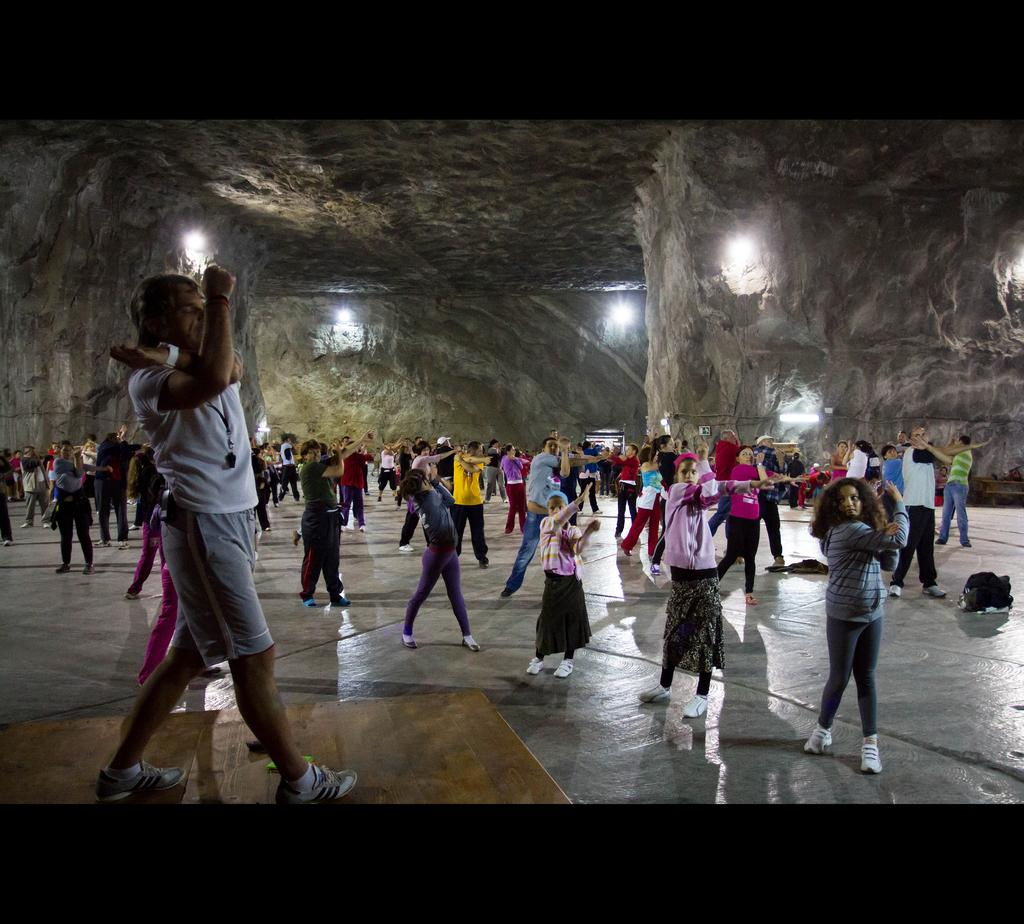What is the main subject of the image? The main subject of the image is a group of people. Can you describe any objects or items visible in the image? Yes, there is a bag on the right side of the image. What can be seen in the background of the image? There are lights on the walls in the background of the image. What type of thought can be seen swimming in the image? There is no thought or goldfish present in the image; it features a group of people and a bag. Can you describe the hose used by the people in the image? There is no hose visible in the image. 